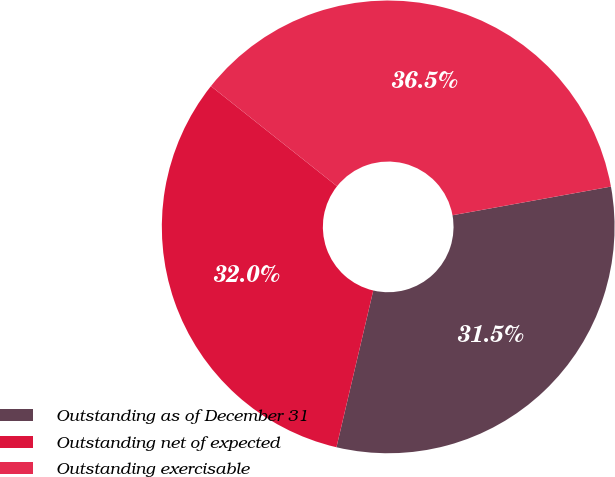Convert chart. <chart><loc_0><loc_0><loc_500><loc_500><pie_chart><fcel>Outstanding as of December 31<fcel>Outstanding net of expected<fcel>Outstanding exercisable<nl><fcel>31.52%<fcel>32.01%<fcel>36.47%<nl></chart> 